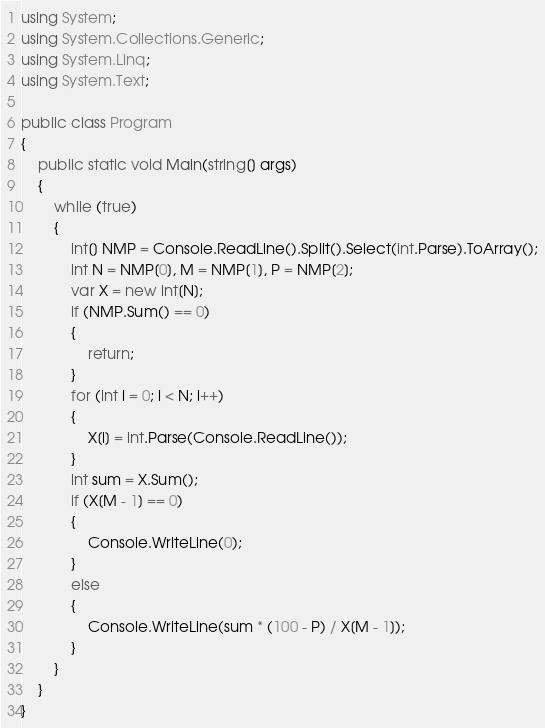<code> <loc_0><loc_0><loc_500><loc_500><_C#_>using System;
using System.Collections.Generic;
using System.Linq;
using System.Text;

public class Program
{
	public static void Main(string[] args)
	{
		while (true)
		{
			int[] NMP = Console.ReadLine().Split().Select(int.Parse).ToArray();
			int N = NMP[0], M = NMP[1], P = NMP[2];
			var X = new int[N];
			if (NMP.Sum() == 0)
			{
				return;
			}
			for (int i = 0; i < N; i++)
			{
				X[i] = int.Parse(Console.ReadLine());
			}
			int sum = X.Sum();
			if (X[M - 1] == 0)
			{
				Console.WriteLine(0);
			}
			else
			{
				Console.WriteLine(sum * (100 - P) / X[M - 1]);
			}
		}
	}
}</code> 